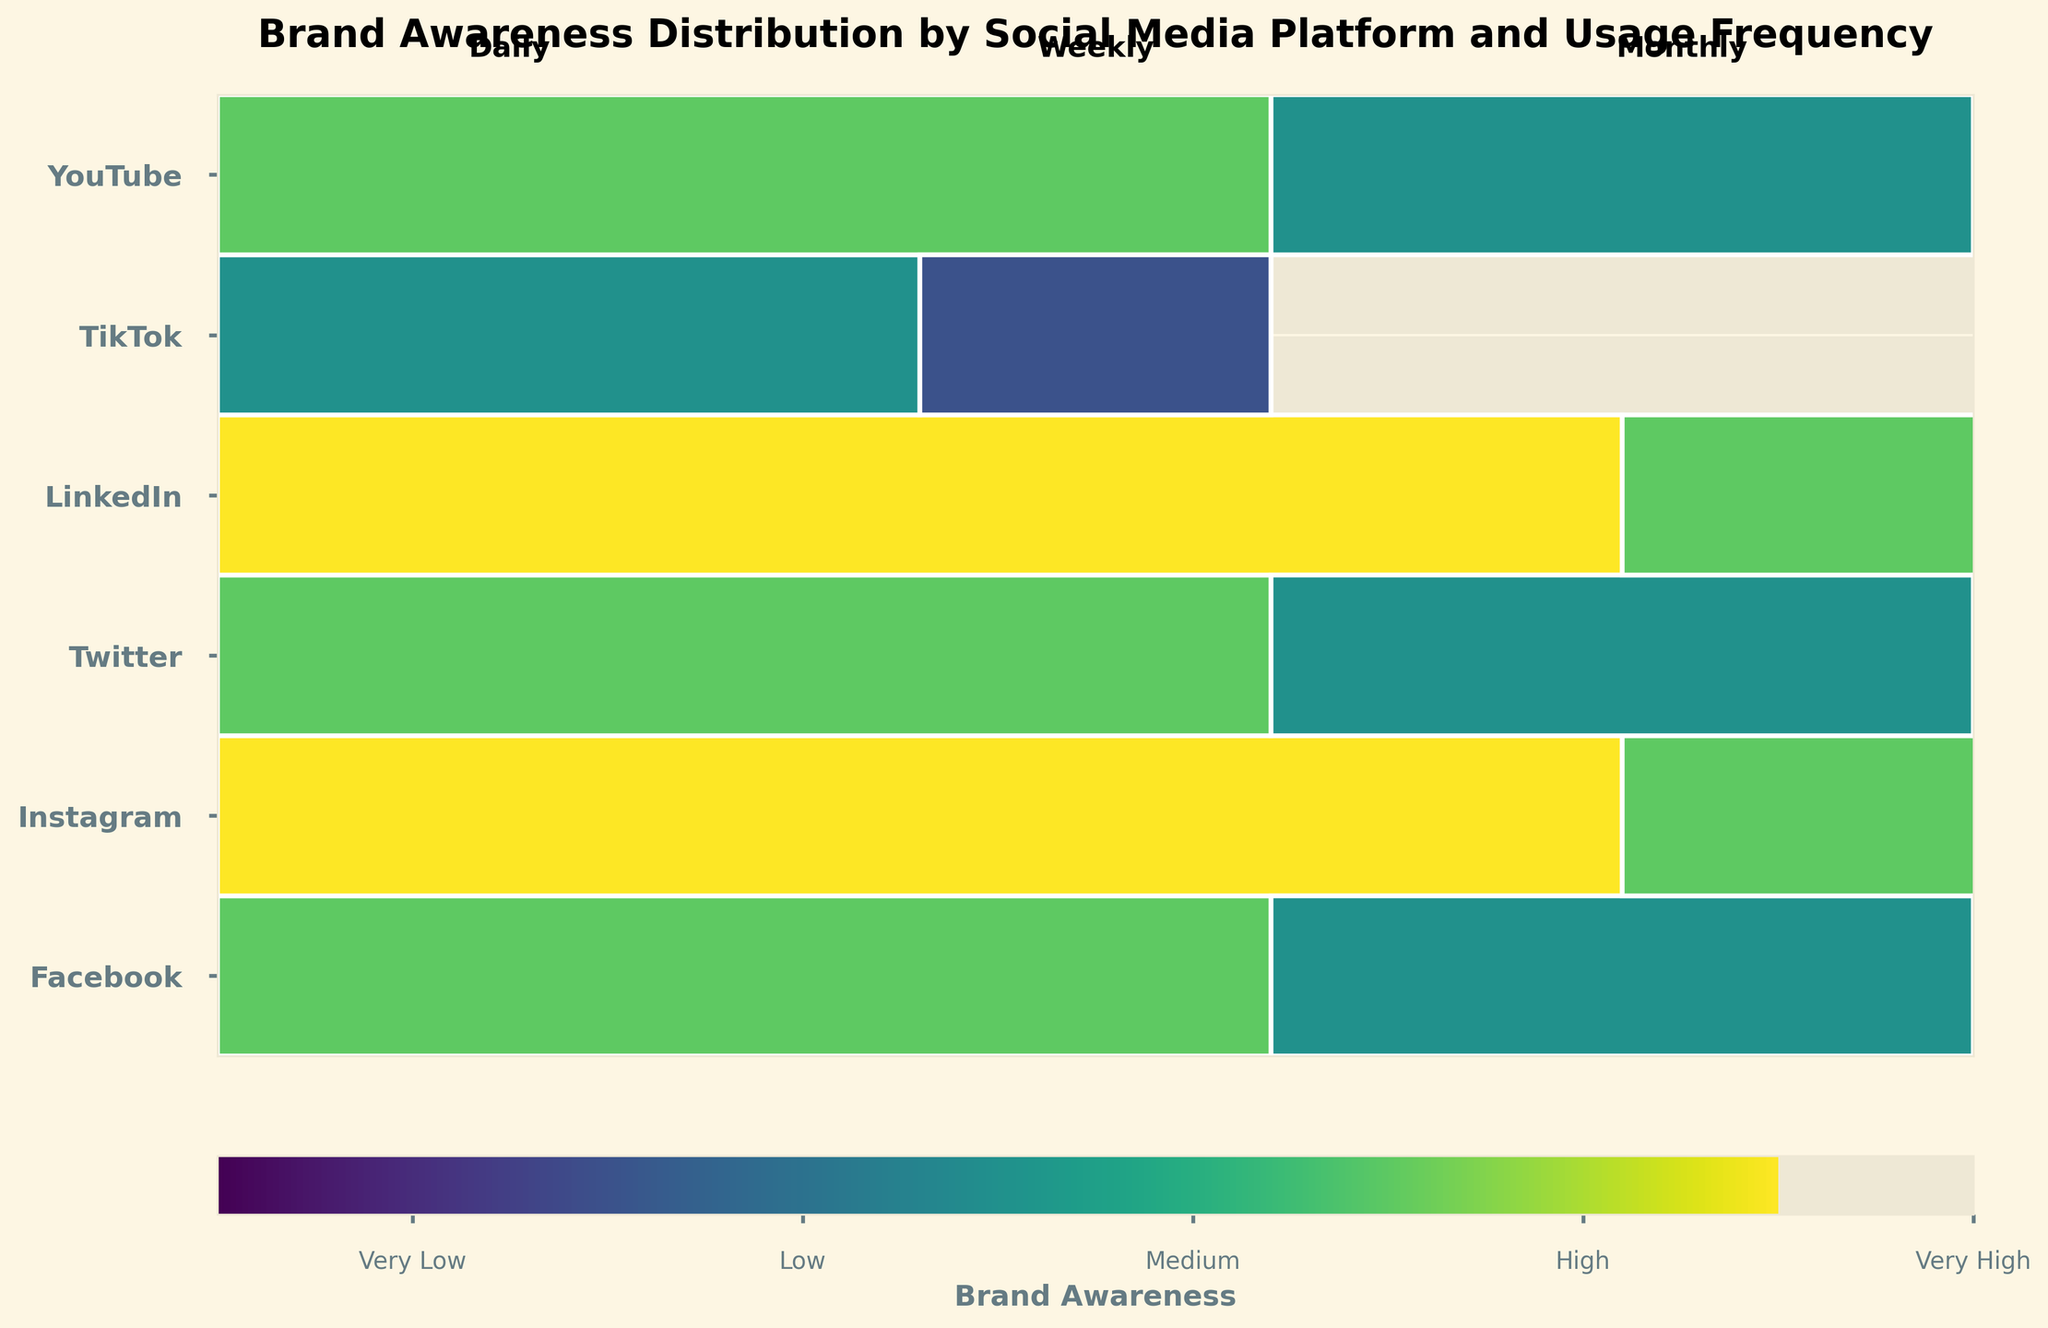What's the title of the figure? The title is typically positioned at the top of the figure, often in larger and bold font for visibility. In this case, it reads "Brand Awareness Distribution by Social Media Platform and Usage Frequency".
Answer: Brand Awareness Distribution by Social Media Platform and Usage Frequency How many social media platforms are represented? The y-axis of the mosaic plot lists the platforms. By counting the unique labels, we can determine that there are six platforms represented: Facebook, Instagram, Twitter, LinkedIn, TikTok, and YouTube.
Answer: Six Which platform has the highest brand awareness for daily use? By identifying the tallest bar in the "Daily" column and matching its color to the "Very High" awareness level in the color bar, we find that both Instagram and TikTok share the highest brand awareness for daily use.
Answer: Instagram, TikTok What color represents medium brand awareness? The color corresponding to the "Medium" label on the color bar tells us which color is used to represent medium brand awareness in the mosaic plot.
Answer: Greenish Are there any platforms with very low brand awareness? If so, which one(s) and for which frequency? The very low brand awareness is represented by the darkest or the lowest value on the color scale. Only Twitter in the monthly category has this dark color.
Answer: Twitter (Monthly) What is the general trend of brand awareness for Facebook across different frequencies of use? Observing the colors in Facebook's row, the brand awareness decreases from daily use (highly aware) to monthly use (low awareness). This shows a decline in brand awareness as the frequency of use decreases.
Answer: Decreasing Compare the brand awareness trends between Instagram and Twitter. By examining the colors from left to right for each platform, Instagram's brand awareness starts very high and decreases to medium from daily to monthly use, whereas Twitter starts medium and decreases to very low over the same period.
Answer: Instagram: Decreasing; Twitter: Fast Decreasing How does LinkedIn's brand awareness on a weekly basis compare to YouTube's weekly brand awareness? By comparing the colors of LinkedIn and YouTube in the "Weekly" column, we see both have the same color corresponding to medium awareness.
Answer: They are equal (both medium) What is the average brand awareness level across all platforms for daily use? For daily use, assign a numerical value to each brand awareness level (Very High=4, High=3, Medium=2, Low=1, Very Low=0), find the values, sum them up (4 for Instagram, 4 for TikTok, 3 for Facebook, 3 for LinkedIn, 2 for Twitter, 3 for YouTube) and divide by the number of platforms (6). The average is (4+4+3+3+2+3)/6.
Answer: 3.17 